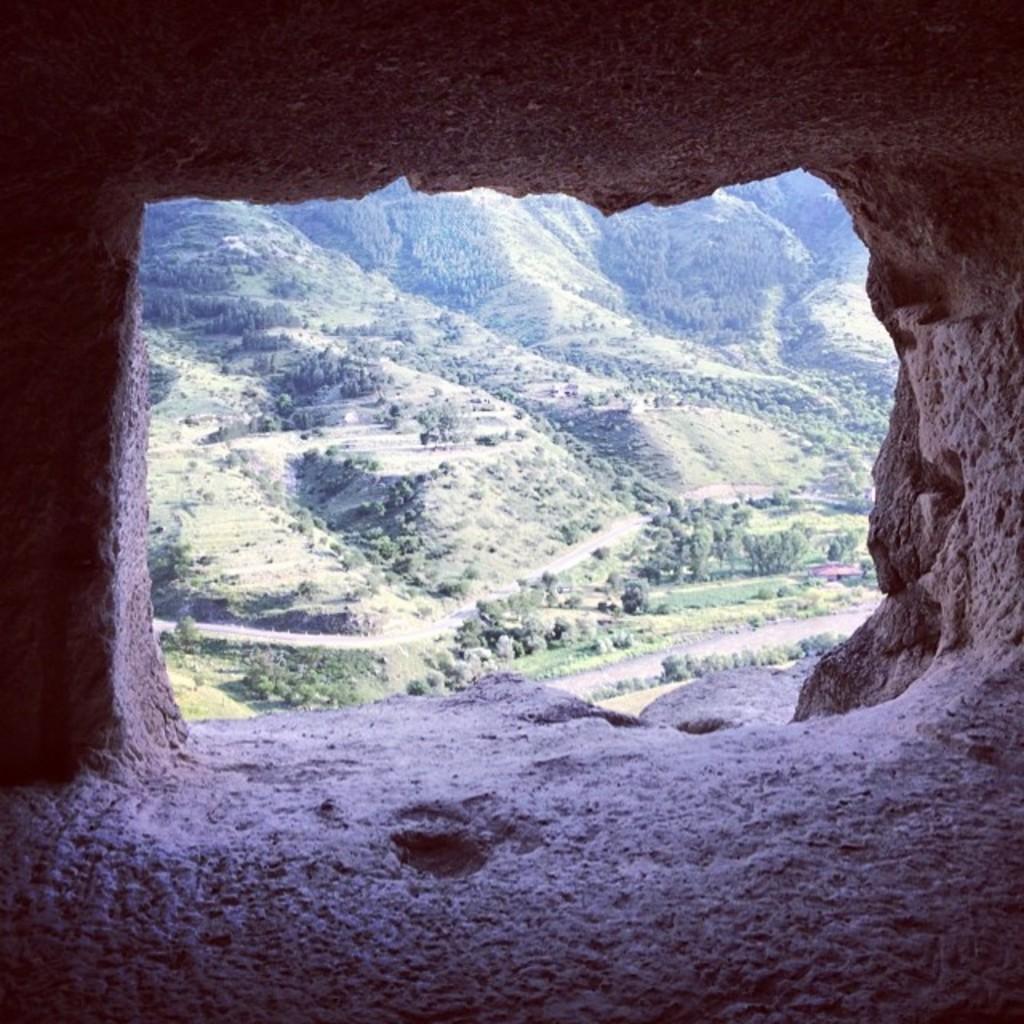Please provide a concise description of this image. This image is clicked from a cave, in the front there are hills with plants and trees all over it. 